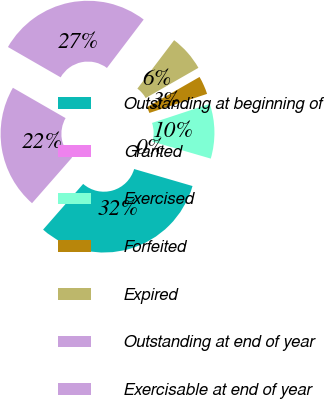Convert chart to OTSL. <chart><loc_0><loc_0><loc_500><loc_500><pie_chart><fcel>Outstanding at beginning of<fcel>Granted<fcel>Exercised<fcel>Forfeited<fcel>Expired<fcel>Outstanding at end of year<fcel>Exercisable at end of year<nl><fcel>31.95%<fcel>0.0%<fcel>9.59%<fcel>3.2%<fcel>6.39%<fcel>27.02%<fcel>21.86%<nl></chart> 